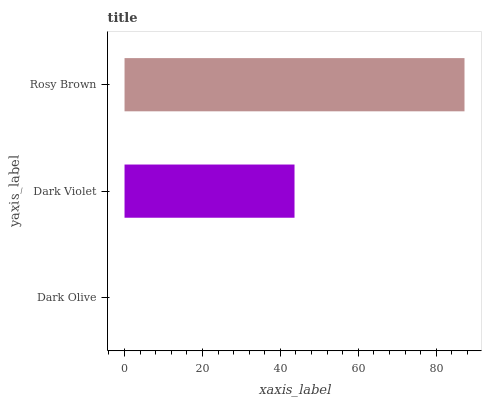Is Dark Olive the minimum?
Answer yes or no. Yes. Is Rosy Brown the maximum?
Answer yes or no. Yes. Is Dark Violet the minimum?
Answer yes or no. No. Is Dark Violet the maximum?
Answer yes or no. No. Is Dark Violet greater than Dark Olive?
Answer yes or no. Yes. Is Dark Olive less than Dark Violet?
Answer yes or no. Yes. Is Dark Olive greater than Dark Violet?
Answer yes or no. No. Is Dark Violet less than Dark Olive?
Answer yes or no. No. Is Dark Violet the high median?
Answer yes or no. Yes. Is Dark Violet the low median?
Answer yes or no. Yes. Is Rosy Brown the high median?
Answer yes or no. No. Is Rosy Brown the low median?
Answer yes or no. No. 